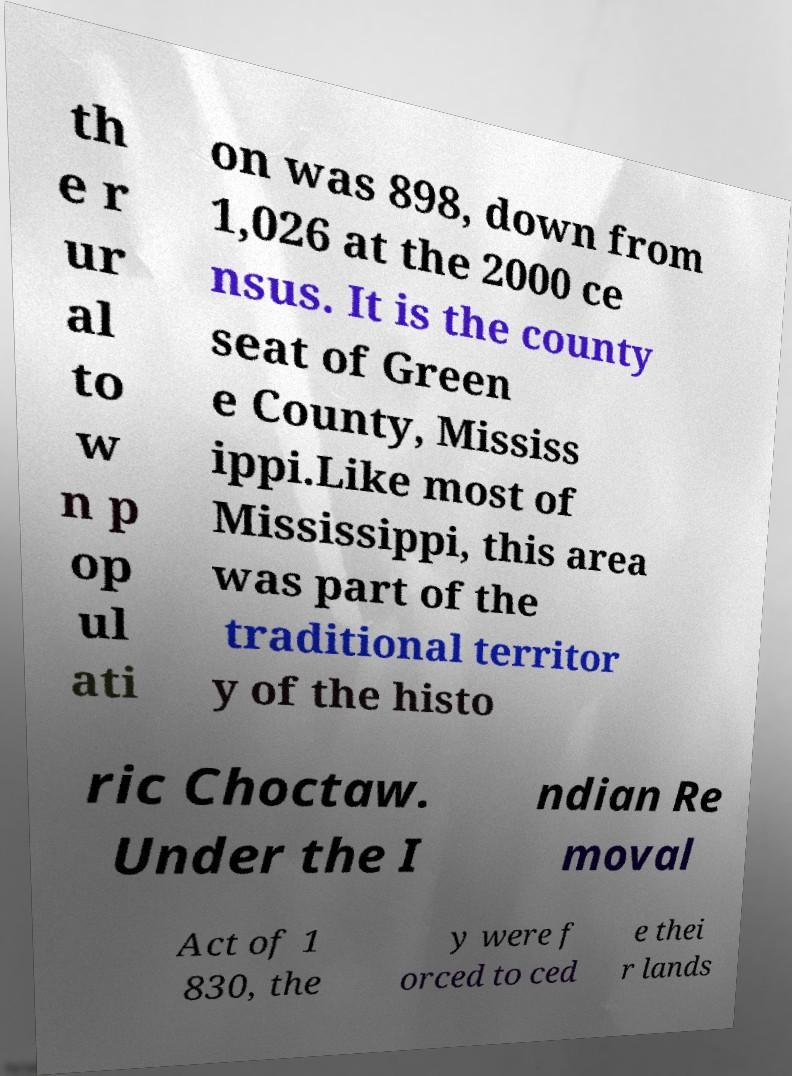Please identify and transcribe the text found in this image. th e r ur al to w n p op ul ati on was 898, down from 1,026 at the 2000 ce nsus. It is the county seat of Green e County, Mississ ippi.Like most of Mississippi, this area was part of the traditional territor y of the histo ric Choctaw. Under the I ndian Re moval Act of 1 830, the y were f orced to ced e thei r lands 